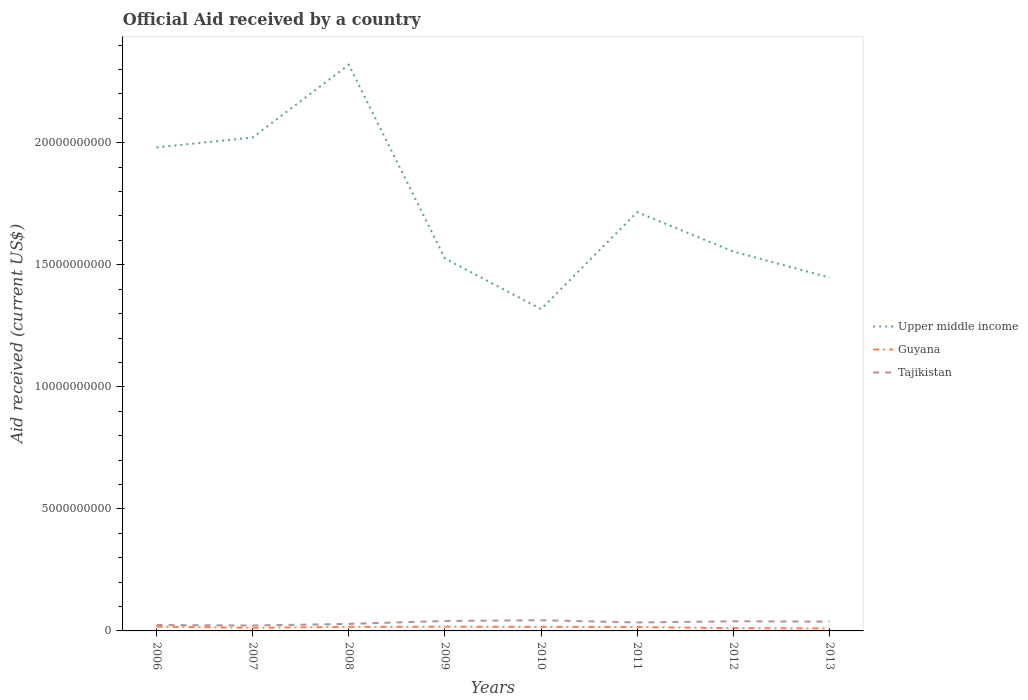How many different coloured lines are there?
Offer a terse response. 3. Is the number of lines equal to the number of legend labels?
Provide a succinct answer. Yes. Across all years, what is the maximum net official aid received in Upper middle income?
Your answer should be very brief. 1.32e+1. What is the total net official aid received in Guyana in the graph?
Offer a very short reply. 7.15e+07. What is the difference between the highest and the second highest net official aid received in Tajikistan?
Provide a succinct answer. 2.15e+08. What is the difference between the highest and the lowest net official aid received in Upper middle income?
Offer a terse response. 3. Is the net official aid received in Upper middle income strictly greater than the net official aid received in Tajikistan over the years?
Offer a very short reply. No. How many years are there in the graph?
Your response must be concise. 8. What is the difference between two consecutive major ticks on the Y-axis?
Give a very brief answer. 5.00e+09. Are the values on the major ticks of Y-axis written in scientific E-notation?
Provide a succinct answer. No. Does the graph contain any zero values?
Offer a very short reply. No. How many legend labels are there?
Provide a succinct answer. 3. How are the legend labels stacked?
Offer a very short reply. Vertical. What is the title of the graph?
Provide a succinct answer. Official Aid received by a country. What is the label or title of the X-axis?
Offer a very short reply. Years. What is the label or title of the Y-axis?
Your response must be concise. Aid received (current US$). What is the Aid received (current US$) in Upper middle income in 2006?
Give a very brief answer. 1.98e+1. What is the Aid received (current US$) of Guyana in 2006?
Provide a short and direct response. 1.74e+08. What is the Aid received (current US$) of Tajikistan in 2006?
Offer a terse response. 2.41e+08. What is the Aid received (current US$) of Upper middle income in 2007?
Offer a terse response. 2.02e+1. What is the Aid received (current US$) in Guyana in 2007?
Provide a succinct answer. 1.28e+08. What is the Aid received (current US$) of Tajikistan in 2007?
Offer a very short reply. 2.22e+08. What is the Aid received (current US$) in Upper middle income in 2008?
Keep it short and to the point. 2.32e+1. What is the Aid received (current US$) in Guyana in 2008?
Offer a terse response. 1.66e+08. What is the Aid received (current US$) in Tajikistan in 2008?
Keep it short and to the point. 2.89e+08. What is the Aid received (current US$) of Upper middle income in 2009?
Your answer should be compact. 1.53e+1. What is the Aid received (current US$) of Guyana in 2009?
Make the answer very short. 1.73e+08. What is the Aid received (current US$) in Tajikistan in 2009?
Ensure brevity in your answer.  4.08e+08. What is the Aid received (current US$) of Upper middle income in 2010?
Offer a terse response. 1.32e+1. What is the Aid received (current US$) in Guyana in 2010?
Your answer should be compact. 1.67e+08. What is the Aid received (current US$) of Tajikistan in 2010?
Offer a terse response. 4.37e+08. What is the Aid received (current US$) in Upper middle income in 2011?
Ensure brevity in your answer.  1.72e+1. What is the Aid received (current US$) of Guyana in 2011?
Offer a terse response. 1.59e+08. What is the Aid received (current US$) of Tajikistan in 2011?
Offer a terse response. 3.48e+08. What is the Aid received (current US$) of Upper middle income in 2012?
Your answer should be very brief. 1.55e+1. What is the Aid received (current US$) in Guyana in 2012?
Make the answer very short. 1.14e+08. What is the Aid received (current US$) of Tajikistan in 2012?
Your answer should be compact. 3.94e+08. What is the Aid received (current US$) of Upper middle income in 2013?
Make the answer very short. 1.45e+1. What is the Aid received (current US$) of Guyana in 2013?
Make the answer very short. 1.02e+08. What is the Aid received (current US$) of Tajikistan in 2013?
Your answer should be very brief. 3.82e+08. Across all years, what is the maximum Aid received (current US$) of Upper middle income?
Your answer should be very brief. 2.32e+1. Across all years, what is the maximum Aid received (current US$) of Guyana?
Your response must be concise. 1.74e+08. Across all years, what is the maximum Aid received (current US$) in Tajikistan?
Provide a succinct answer. 4.37e+08. Across all years, what is the minimum Aid received (current US$) of Upper middle income?
Provide a short and direct response. 1.32e+1. Across all years, what is the minimum Aid received (current US$) of Guyana?
Make the answer very short. 1.02e+08. Across all years, what is the minimum Aid received (current US$) in Tajikistan?
Give a very brief answer. 2.22e+08. What is the total Aid received (current US$) in Upper middle income in the graph?
Keep it short and to the point. 1.39e+11. What is the total Aid received (current US$) of Guyana in the graph?
Offer a very short reply. 1.18e+09. What is the total Aid received (current US$) of Tajikistan in the graph?
Your response must be concise. 2.72e+09. What is the difference between the Aid received (current US$) of Upper middle income in 2006 and that in 2007?
Your answer should be compact. -4.08e+08. What is the difference between the Aid received (current US$) in Guyana in 2006 and that in 2007?
Provide a succinct answer. 4.65e+07. What is the difference between the Aid received (current US$) of Tajikistan in 2006 and that in 2007?
Give a very brief answer. 1.91e+07. What is the difference between the Aid received (current US$) of Upper middle income in 2006 and that in 2008?
Your response must be concise. -3.39e+09. What is the difference between the Aid received (current US$) in Guyana in 2006 and that in 2008?
Make the answer very short. 8.04e+06. What is the difference between the Aid received (current US$) of Tajikistan in 2006 and that in 2008?
Provide a short and direct response. -4.74e+07. What is the difference between the Aid received (current US$) of Upper middle income in 2006 and that in 2009?
Give a very brief answer. 4.55e+09. What is the difference between the Aid received (current US$) in Guyana in 2006 and that in 2009?
Your answer should be very brief. 9.70e+05. What is the difference between the Aid received (current US$) in Tajikistan in 2006 and that in 2009?
Offer a very short reply. -1.67e+08. What is the difference between the Aid received (current US$) of Upper middle income in 2006 and that in 2010?
Your answer should be very brief. 6.62e+09. What is the difference between the Aid received (current US$) of Guyana in 2006 and that in 2010?
Ensure brevity in your answer.  7.29e+06. What is the difference between the Aid received (current US$) in Tajikistan in 2006 and that in 2010?
Offer a terse response. -1.95e+08. What is the difference between the Aid received (current US$) in Upper middle income in 2006 and that in 2011?
Your answer should be very brief. 2.65e+09. What is the difference between the Aid received (current US$) in Guyana in 2006 and that in 2011?
Make the answer very short. 1.56e+07. What is the difference between the Aid received (current US$) of Tajikistan in 2006 and that in 2011?
Keep it short and to the point. -1.06e+08. What is the difference between the Aid received (current US$) in Upper middle income in 2006 and that in 2012?
Offer a terse response. 4.26e+09. What is the difference between the Aid received (current US$) of Guyana in 2006 and that in 2012?
Provide a short and direct response. 5.99e+07. What is the difference between the Aid received (current US$) of Tajikistan in 2006 and that in 2012?
Offer a very short reply. -1.53e+08. What is the difference between the Aid received (current US$) of Upper middle income in 2006 and that in 2013?
Give a very brief answer. 5.33e+09. What is the difference between the Aid received (current US$) of Guyana in 2006 and that in 2013?
Make the answer very short. 7.24e+07. What is the difference between the Aid received (current US$) in Tajikistan in 2006 and that in 2013?
Offer a very short reply. -1.41e+08. What is the difference between the Aid received (current US$) in Upper middle income in 2007 and that in 2008?
Keep it short and to the point. -2.98e+09. What is the difference between the Aid received (current US$) in Guyana in 2007 and that in 2008?
Your answer should be very brief. -3.84e+07. What is the difference between the Aid received (current US$) of Tajikistan in 2007 and that in 2008?
Offer a terse response. -6.66e+07. What is the difference between the Aid received (current US$) of Upper middle income in 2007 and that in 2009?
Your answer should be compact. 4.96e+09. What is the difference between the Aid received (current US$) in Guyana in 2007 and that in 2009?
Your response must be concise. -4.55e+07. What is the difference between the Aid received (current US$) in Tajikistan in 2007 and that in 2009?
Provide a short and direct response. -1.86e+08. What is the difference between the Aid received (current US$) in Upper middle income in 2007 and that in 2010?
Ensure brevity in your answer.  7.03e+09. What is the difference between the Aid received (current US$) in Guyana in 2007 and that in 2010?
Your response must be concise. -3.92e+07. What is the difference between the Aid received (current US$) in Tajikistan in 2007 and that in 2010?
Your answer should be compact. -2.15e+08. What is the difference between the Aid received (current US$) of Upper middle income in 2007 and that in 2011?
Make the answer very short. 3.06e+09. What is the difference between the Aid received (current US$) in Guyana in 2007 and that in 2011?
Your answer should be compact. -3.09e+07. What is the difference between the Aid received (current US$) of Tajikistan in 2007 and that in 2011?
Provide a short and direct response. -1.25e+08. What is the difference between the Aid received (current US$) of Upper middle income in 2007 and that in 2012?
Your response must be concise. 4.67e+09. What is the difference between the Aid received (current US$) of Guyana in 2007 and that in 2012?
Give a very brief answer. 1.34e+07. What is the difference between the Aid received (current US$) of Tajikistan in 2007 and that in 2012?
Make the answer very short. -1.72e+08. What is the difference between the Aid received (current US$) in Upper middle income in 2007 and that in 2013?
Ensure brevity in your answer.  5.74e+09. What is the difference between the Aid received (current US$) of Guyana in 2007 and that in 2013?
Keep it short and to the point. 2.60e+07. What is the difference between the Aid received (current US$) of Tajikistan in 2007 and that in 2013?
Your answer should be compact. -1.60e+08. What is the difference between the Aid received (current US$) in Upper middle income in 2008 and that in 2009?
Give a very brief answer. 7.94e+09. What is the difference between the Aid received (current US$) of Guyana in 2008 and that in 2009?
Offer a terse response. -7.07e+06. What is the difference between the Aid received (current US$) of Tajikistan in 2008 and that in 2009?
Provide a short and direct response. -1.19e+08. What is the difference between the Aid received (current US$) in Upper middle income in 2008 and that in 2010?
Provide a short and direct response. 1.00e+1. What is the difference between the Aid received (current US$) of Guyana in 2008 and that in 2010?
Provide a succinct answer. -7.50e+05. What is the difference between the Aid received (current US$) in Tajikistan in 2008 and that in 2010?
Ensure brevity in your answer.  -1.48e+08. What is the difference between the Aid received (current US$) in Upper middle income in 2008 and that in 2011?
Give a very brief answer. 6.04e+09. What is the difference between the Aid received (current US$) in Guyana in 2008 and that in 2011?
Make the answer very short. 7.51e+06. What is the difference between the Aid received (current US$) in Tajikistan in 2008 and that in 2011?
Ensure brevity in your answer.  -5.88e+07. What is the difference between the Aid received (current US$) in Upper middle income in 2008 and that in 2012?
Offer a terse response. 7.65e+09. What is the difference between the Aid received (current US$) in Guyana in 2008 and that in 2012?
Offer a very short reply. 5.18e+07. What is the difference between the Aid received (current US$) in Tajikistan in 2008 and that in 2012?
Offer a very short reply. -1.05e+08. What is the difference between the Aid received (current US$) in Upper middle income in 2008 and that in 2013?
Make the answer very short. 8.72e+09. What is the difference between the Aid received (current US$) in Guyana in 2008 and that in 2013?
Keep it short and to the point. 6.44e+07. What is the difference between the Aid received (current US$) of Tajikistan in 2008 and that in 2013?
Offer a very short reply. -9.35e+07. What is the difference between the Aid received (current US$) in Upper middle income in 2009 and that in 2010?
Your answer should be compact. 2.07e+09. What is the difference between the Aid received (current US$) in Guyana in 2009 and that in 2010?
Offer a very short reply. 6.32e+06. What is the difference between the Aid received (current US$) of Tajikistan in 2009 and that in 2010?
Keep it short and to the point. -2.85e+07. What is the difference between the Aid received (current US$) of Upper middle income in 2009 and that in 2011?
Your response must be concise. -1.90e+09. What is the difference between the Aid received (current US$) in Guyana in 2009 and that in 2011?
Make the answer very short. 1.46e+07. What is the difference between the Aid received (current US$) in Tajikistan in 2009 and that in 2011?
Ensure brevity in your answer.  6.06e+07. What is the difference between the Aid received (current US$) in Upper middle income in 2009 and that in 2012?
Provide a short and direct response. -2.86e+08. What is the difference between the Aid received (current US$) of Guyana in 2009 and that in 2012?
Provide a short and direct response. 5.89e+07. What is the difference between the Aid received (current US$) of Tajikistan in 2009 and that in 2012?
Your response must be concise. 1.42e+07. What is the difference between the Aid received (current US$) of Upper middle income in 2009 and that in 2013?
Provide a short and direct response. 7.81e+08. What is the difference between the Aid received (current US$) in Guyana in 2009 and that in 2013?
Give a very brief answer. 7.15e+07. What is the difference between the Aid received (current US$) of Tajikistan in 2009 and that in 2013?
Provide a short and direct response. 2.59e+07. What is the difference between the Aid received (current US$) of Upper middle income in 2010 and that in 2011?
Your answer should be compact. -3.97e+09. What is the difference between the Aid received (current US$) of Guyana in 2010 and that in 2011?
Your answer should be compact. 8.26e+06. What is the difference between the Aid received (current US$) in Tajikistan in 2010 and that in 2011?
Ensure brevity in your answer.  8.91e+07. What is the difference between the Aid received (current US$) in Upper middle income in 2010 and that in 2012?
Your response must be concise. -2.36e+09. What is the difference between the Aid received (current US$) of Guyana in 2010 and that in 2012?
Provide a succinct answer. 5.26e+07. What is the difference between the Aid received (current US$) in Tajikistan in 2010 and that in 2012?
Provide a short and direct response. 4.27e+07. What is the difference between the Aid received (current US$) in Upper middle income in 2010 and that in 2013?
Provide a succinct answer. -1.29e+09. What is the difference between the Aid received (current US$) in Guyana in 2010 and that in 2013?
Your answer should be very brief. 6.52e+07. What is the difference between the Aid received (current US$) in Tajikistan in 2010 and that in 2013?
Your answer should be compact. 5.44e+07. What is the difference between the Aid received (current US$) of Upper middle income in 2011 and that in 2012?
Make the answer very short. 1.62e+09. What is the difference between the Aid received (current US$) in Guyana in 2011 and that in 2012?
Offer a very short reply. 4.43e+07. What is the difference between the Aid received (current US$) of Tajikistan in 2011 and that in 2012?
Provide a succinct answer. -4.64e+07. What is the difference between the Aid received (current US$) in Upper middle income in 2011 and that in 2013?
Your answer should be very brief. 2.68e+09. What is the difference between the Aid received (current US$) in Guyana in 2011 and that in 2013?
Provide a succinct answer. 5.69e+07. What is the difference between the Aid received (current US$) in Tajikistan in 2011 and that in 2013?
Your answer should be very brief. -3.47e+07. What is the difference between the Aid received (current US$) of Upper middle income in 2012 and that in 2013?
Offer a terse response. 1.07e+09. What is the difference between the Aid received (current US$) in Guyana in 2012 and that in 2013?
Your answer should be compact. 1.26e+07. What is the difference between the Aid received (current US$) of Tajikistan in 2012 and that in 2013?
Offer a very short reply. 1.17e+07. What is the difference between the Aid received (current US$) in Upper middle income in 2006 and the Aid received (current US$) in Guyana in 2007?
Make the answer very short. 1.97e+1. What is the difference between the Aid received (current US$) in Upper middle income in 2006 and the Aid received (current US$) in Tajikistan in 2007?
Ensure brevity in your answer.  1.96e+1. What is the difference between the Aid received (current US$) in Guyana in 2006 and the Aid received (current US$) in Tajikistan in 2007?
Give a very brief answer. -4.78e+07. What is the difference between the Aid received (current US$) in Upper middle income in 2006 and the Aid received (current US$) in Guyana in 2008?
Give a very brief answer. 1.96e+1. What is the difference between the Aid received (current US$) in Upper middle income in 2006 and the Aid received (current US$) in Tajikistan in 2008?
Your answer should be very brief. 1.95e+1. What is the difference between the Aid received (current US$) in Guyana in 2006 and the Aid received (current US$) in Tajikistan in 2008?
Provide a short and direct response. -1.14e+08. What is the difference between the Aid received (current US$) in Upper middle income in 2006 and the Aid received (current US$) in Guyana in 2009?
Your answer should be compact. 1.96e+1. What is the difference between the Aid received (current US$) in Upper middle income in 2006 and the Aid received (current US$) in Tajikistan in 2009?
Give a very brief answer. 1.94e+1. What is the difference between the Aid received (current US$) of Guyana in 2006 and the Aid received (current US$) of Tajikistan in 2009?
Offer a very short reply. -2.34e+08. What is the difference between the Aid received (current US$) of Upper middle income in 2006 and the Aid received (current US$) of Guyana in 2010?
Your answer should be very brief. 1.96e+1. What is the difference between the Aid received (current US$) in Upper middle income in 2006 and the Aid received (current US$) in Tajikistan in 2010?
Provide a short and direct response. 1.94e+1. What is the difference between the Aid received (current US$) in Guyana in 2006 and the Aid received (current US$) in Tajikistan in 2010?
Offer a terse response. -2.62e+08. What is the difference between the Aid received (current US$) of Upper middle income in 2006 and the Aid received (current US$) of Guyana in 2011?
Make the answer very short. 1.96e+1. What is the difference between the Aid received (current US$) in Upper middle income in 2006 and the Aid received (current US$) in Tajikistan in 2011?
Offer a terse response. 1.95e+1. What is the difference between the Aid received (current US$) of Guyana in 2006 and the Aid received (current US$) of Tajikistan in 2011?
Offer a terse response. -1.73e+08. What is the difference between the Aid received (current US$) of Upper middle income in 2006 and the Aid received (current US$) of Guyana in 2012?
Make the answer very short. 1.97e+1. What is the difference between the Aid received (current US$) of Upper middle income in 2006 and the Aid received (current US$) of Tajikistan in 2012?
Your answer should be very brief. 1.94e+1. What is the difference between the Aid received (current US$) in Guyana in 2006 and the Aid received (current US$) in Tajikistan in 2012?
Offer a very short reply. -2.20e+08. What is the difference between the Aid received (current US$) of Upper middle income in 2006 and the Aid received (current US$) of Guyana in 2013?
Provide a short and direct response. 1.97e+1. What is the difference between the Aid received (current US$) in Upper middle income in 2006 and the Aid received (current US$) in Tajikistan in 2013?
Your answer should be very brief. 1.94e+1. What is the difference between the Aid received (current US$) in Guyana in 2006 and the Aid received (current US$) in Tajikistan in 2013?
Your answer should be compact. -2.08e+08. What is the difference between the Aid received (current US$) of Upper middle income in 2007 and the Aid received (current US$) of Guyana in 2008?
Your answer should be very brief. 2.00e+1. What is the difference between the Aid received (current US$) in Upper middle income in 2007 and the Aid received (current US$) in Tajikistan in 2008?
Offer a terse response. 1.99e+1. What is the difference between the Aid received (current US$) of Guyana in 2007 and the Aid received (current US$) of Tajikistan in 2008?
Offer a very short reply. -1.61e+08. What is the difference between the Aid received (current US$) in Upper middle income in 2007 and the Aid received (current US$) in Guyana in 2009?
Make the answer very short. 2.00e+1. What is the difference between the Aid received (current US$) of Upper middle income in 2007 and the Aid received (current US$) of Tajikistan in 2009?
Keep it short and to the point. 1.98e+1. What is the difference between the Aid received (current US$) in Guyana in 2007 and the Aid received (current US$) in Tajikistan in 2009?
Give a very brief answer. -2.80e+08. What is the difference between the Aid received (current US$) in Upper middle income in 2007 and the Aid received (current US$) in Guyana in 2010?
Provide a succinct answer. 2.00e+1. What is the difference between the Aid received (current US$) of Upper middle income in 2007 and the Aid received (current US$) of Tajikistan in 2010?
Your answer should be compact. 1.98e+1. What is the difference between the Aid received (current US$) of Guyana in 2007 and the Aid received (current US$) of Tajikistan in 2010?
Provide a short and direct response. -3.09e+08. What is the difference between the Aid received (current US$) in Upper middle income in 2007 and the Aid received (current US$) in Guyana in 2011?
Ensure brevity in your answer.  2.01e+1. What is the difference between the Aid received (current US$) of Upper middle income in 2007 and the Aid received (current US$) of Tajikistan in 2011?
Make the answer very short. 1.99e+1. What is the difference between the Aid received (current US$) in Guyana in 2007 and the Aid received (current US$) in Tajikistan in 2011?
Provide a short and direct response. -2.20e+08. What is the difference between the Aid received (current US$) in Upper middle income in 2007 and the Aid received (current US$) in Guyana in 2012?
Provide a succinct answer. 2.01e+1. What is the difference between the Aid received (current US$) of Upper middle income in 2007 and the Aid received (current US$) of Tajikistan in 2012?
Make the answer very short. 1.98e+1. What is the difference between the Aid received (current US$) of Guyana in 2007 and the Aid received (current US$) of Tajikistan in 2012?
Make the answer very short. -2.66e+08. What is the difference between the Aid received (current US$) of Upper middle income in 2007 and the Aid received (current US$) of Guyana in 2013?
Your response must be concise. 2.01e+1. What is the difference between the Aid received (current US$) in Upper middle income in 2007 and the Aid received (current US$) in Tajikistan in 2013?
Provide a short and direct response. 1.98e+1. What is the difference between the Aid received (current US$) of Guyana in 2007 and the Aid received (current US$) of Tajikistan in 2013?
Provide a short and direct response. -2.54e+08. What is the difference between the Aid received (current US$) of Upper middle income in 2008 and the Aid received (current US$) of Guyana in 2009?
Ensure brevity in your answer.  2.30e+1. What is the difference between the Aid received (current US$) in Upper middle income in 2008 and the Aid received (current US$) in Tajikistan in 2009?
Ensure brevity in your answer.  2.28e+1. What is the difference between the Aid received (current US$) in Guyana in 2008 and the Aid received (current US$) in Tajikistan in 2009?
Make the answer very short. -2.42e+08. What is the difference between the Aid received (current US$) in Upper middle income in 2008 and the Aid received (current US$) in Guyana in 2010?
Keep it short and to the point. 2.30e+1. What is the difference between the Aid received (current US$) of Upper middle income in 2008 and the Aid received (current US$) of Tajikistan in 2010?
Provide a short and direct response. 2.28e+1. What is the difference between the Aid received (current US$) of Guyana in 2008 and the Aid received (current US$) of Tajikistan in 2010?
Keep it short and to the point. -2.70e+08. What is the difference between the Aid received (current US$) in Upper middle income in 2008 and the Aid received (current US$) in Guyana in 2011?
Provide a short and direct response. 2.30e+1. What is the difference between the Aid received (current US$) in Upper middle income in 2008 and the Aid received (current US$) in Tajikistan in 2011?
Provide a succinct answer. 2.28e+1. What is the difference between the Aid received (current US$) of Guyana in 2008 and the Aid received (current US$) of Tajikistan in 2011?
Keep it short and to the point. -1.81e+08. What is the difference between the Aid received (current US$) in Upper middle income in 2008 and the Aid received (current US$) in Guyana in 2012?
Keep it short and to the point. 2.31e+1. What is the difference between the Aid received (current US$) of Upper middle income in 2008 and the Aid received (current US$) of Tajikistan in 2012?
Make the answer very short. 2.28e+1. What is the difference between the Aid received (current US$) of Guyana in 2008 and the Aid received (current US$) of Tajikistan in 2012?
Your answer should be very brief. -2.28e+08. What is the difference between the Aid received (current US$) of Upper middle income in 2008 and the Aid received (current US$) of Guyana in 2013?
Offer a very short reply. 2.31e+1. What is the difference between the Aid received (current US$) in Upper middle income in 2008 and the Aid received (current US$) in Tajikistan in 2013?
Keep it short and to the point. 2.28e+1. What is the difference between the Aid received (current US$) in Guyana in 2008 and the Aid received (current US$) in Tajikistan in 2013?
Give a very brief answer. -2.16e+08. What is the difference between the Aid received (current US$) of Upper middle income in 2009 and the Aid received (current US$) of Guyana in 2010?
Offer a very short reply. 1.51e+1. What is the difference between the Aid received (current US$) of Upper middle income in 2009 and the Aid received (current US$) of Tajikistan in 2010?
Offer a very short reply. 1.48e+1. What is the difference between the Aid received (current US$) in Guyana in 2009 and the Aid received (current US$) in Tajikistan in 2010?
Ensure brevity in your answer.  -2.63e+08. What is the difference between the Aid received (current US$) of Upper middle income in 2009 and the Aid received (current US$) of Guyana in 2011?
Keep it short and to the point. 1.51e+1. What is the difference between the Aid received (current US$) of Upper middle income in 2009 and the Aid received (current US$) of Tajikistan in 2011?
Your answer should be very brief. 1.49e+1. What is the difference between the Aid received (current US$) in Guyana in 2009 and the Aid received (current US$) in Tajikistan in 2011?
Offer a very short reply. -1.74e+08. What is the difference between the Aid received (current US$) in Upper middle income in 2009 and the Aid received (current US$) in Guyana in 2012?
Your response must be concise. 1.51e+1. What is the difference between the Aid received (current US$) in Upper middle income in 2009 and the Aid received (current US$) in Tajikistan in 2012?
Your response must be concise. 1.49e+1. What is the difference between the Aid received (current US$) of Guyana in 2009 and the Aid received (current US$) of Tajikistan in 2012?
Make the answer very short. -2.21e+08. What is the difference between the Aid received (current US$) of Upper middle income in 2009 and the Aid received (current US$) of Guyana in 2013?
Give a very brief answer. 1.52e+1. What is the difference between the Aid received (current US$) in Upper middle income in 2009 and the Aid received (current US$) in Tajikistan in 2013?
Your response must be concise. 1.49e+1. What is the difference between the Aid received (current US$) of Guyana in 2009 and the Aid received (current US$) of Tajikistan in 2013?
Your answer should be very brief. -2.09e+08. What is the difference between the Aid received (current US$) in Upper middle income in 2010 and the Aid received (current US$) in Guyana in 2011?
Provide a short and direct response. 1.30e+1. What is the difference between the Aid received (current US$) of Upper middle income in 2010 and the Aid received (current US$) of Tajikistan in 2011?
Your answer should be very brief. 1.28e+1. What is the difference between the Aid received (current US$) in Guyana in 2010 and the Aid received (current US$) in Tajikistan in 2011?
Provide a short and direct response. -1.80e+08. What is the difference between the Aid received (current US$) in Upper middle income in 2010 and the Aid received (current US$) in Guyana in 2012?
Your answer should be very brief. 1.31e+1. What is the difference between the Aid received (current US$) of Upper middle income in 2010 and the Aid received (current US$) of Tajikistan in 2012?
Offer a terse response. 1.28e+1. What is the difference between the Aid received (current US$) of Guyana in 2010 and the Aid received (current US$) of Tajikistan in 2012?
Offer a terse response. -2.27e+08. What is the difference between the Aid received (current US$) of Upper middle income in 2010 and the Aid received (current US$) of Guyana in 2013?
Provide a succinct answer. 1.31e+1. What is the difference between the Aid received (current US$) in Upper middle income in 2010 and the Aid received (current US$) in Tajikistan in 2013?
Keep it short and to the point. 1.28e+1. What is the difference between the Aid received (current US$) of Guyana in 2010 and the Aid received (current US$) of Tajikistan in 2013?
Provide a succinct answer. -2.15e+08. What is the difference between the Aid received (current US$) in Upper middle income in 2011 and the Aid received (current US$) in Guyana in 2012?
Offer a very short reply. 1.70e+1. What is the difference between the Aid received (current US$) in Upper middle income in 2011 and the Aid received (current US$) in Tajikistan in 2012?
Give a very brief answer. 1.68e+1. What is the difference between the Aid received (current US$) in Guyana in 2011 and the Aid received (current US$) in Tajikistan in 2012?
Keep it short and to the point. -2.35e+08. What is the difference between the Aid received (current US$) of Upper middle income in 2011 and the Aid received (current US$) of Guyana in 2013?
Offer a terse response. 1.71e+1. What is the difference between the Aid received (current US$) of Upper middle income in 2011 and the Aid received (current US$) of Tajikistan in 2013?
Keep it short and to the point. 1.68e+1. What is the difference between the Aid received (current US$) of Guyana in 2011 and the Aid received (current US$) of Tajikistan in 2013?
Ensure brevity in your answer.  -2.23e+08. What is the difference between the Aid received (current US$) of Upper middle income in 2012 and the Aid received (current US$) of Guyana in 2013?
Provide a short and direct response. 1.54e+1. What is the difference between the Aid received (current US$) in Upper middle income in 2012 and the Aid received (current US$) in Tajikistan in 2013?
Provide a succinct answer. 1.52e+1. What is the difference between the Aid received (current US$) of Guyana in 2012 and the Aid received (current US$) of Tajikistan in 2013?
Provide a short and direct response. -2.68e+08. What is the average Aid received (current US$) in Upper middle income per year?
Your answer should be compact. 1.74e+1. What is the average Aid received (current US$) in Guyana per year?
Ensure brevity in your answer.  1.48e+08. What is the average Aid received (current US$) in Tajikistan per year?
Provide a short and direct response. 3.40e+08. In the year 2006, what is the difference between the Aid received (current US$) in Upper middle income and Aid received (current US$) in Guyana?
Give a very brief answer. 1.96e+1. In the year 2006, what is the difference between the Aid received (current US$) in Upper middle income and Aid received (current US$) in Tajikistan?
Give a very brief answer. 1.96e+1. In the year 2006, what is the difference between the Aid received (current US$) in Guyana and Aid received (current US$) in Tajikistan?
Provide a succinct answer. -6.69e+07. In the year 2007, what is the difference between the Aid received (current US$) in Upper middle income and Aid received (current US$) in Guyana?
Your response must be concise. 2.01e+1. In the year 2007, what is the difference between the Aid received (current US$) in Upper middle income and Aid received (current US$) in Tajikistan?
Your response must be concise. 2.00e+1. In the year 2007, what is the difference between the Aid received (current US$) of Guyana and Aid received (current US$) of Tajikistan?
Your response must be concise. -9.43e+07. In the year 2008, what is the difference between the Aid received (current US$) of Upper middle income and Aid received (current US$) of Guyana?
Provide a short and direct response. 2.30e+1. In the year 2008, what is the difference between the Aid received (current US$) in Upper middle income and Aid received (current US$) in Tajikistan?
Provide a short and direct response. 2.29e+1. In the year 2008, what is the difference between the Aid received (current US$) in Guyana and Aid received (current US$) in Tajikistan?
Your response must be concise. -1.22e+08. In the year 2009, what is the difference between the Aid received (current US$) in Upper middle income and Aid received (current US$) in Guyana?
Your response must be concise. 1.51e+1. In the year 2009, what is the difference between the Aid received (current US$) of Upper middle income and Aid received (current US$) of Tajikistan?
Your answer should be very brief. 1.48e+1. In the year 2009, what is the difference between the Aid received (current US$) of Guyana and Aid received (current US$) of Tajikistan?
Your answer should be very brief. -2.35e+08. In the year 2010, what is the difference between the Aid received (current US$) of Upper middle income and Aid received (current US$) of Guyana?
Provide a succinct answer. 1.30e+1. In the year 2010, what is the difference between the Aid received (current US$) in Upper middle income and Aid received (current US$) in Tajikistan?
Your answer should be compact. 1.27e+1. In the year 2010, what is the difference between the Aid received (current US$) of Guyana and Aid received (current US$) of Tajikistan?
Give a very brief answer. -2.70e+08. In the year 2011, what is the difference between the Aid received (current US$) of Upper middle income and Aid received (current US$) of Guyana?
Your answer should be compact. 1.70e+1. In the year 2011, what is the difference between the Aid received (current US$) of Upper middle income and Aid received (current US$) of Tajikistan?
Ensure brevity in your answer.  1.68e+1. In the year 2011, what is the difference between the Aid received (current US$) of Guyana and Aid received (current US$) of Tajikistan?
Offer a terse response. -1.89e+08. In the year 2012, what is the difference between the Aid received (current US$) in Upper middle income and Aid received (current US$) in Guyana?
Keep it short and to the point. 1.54e+1. In the year 2012, what is the difference between the Aid received (current US$) in Upper middle income and Aid received (current US$) in Tajikistan?
Your answer should be compact. 1.51e+1. In the year 2012, what is the difference between the Aid received (current US$) in Guyana and Aid received (current US$) in Tajikistan?
Your answer should be very brief. -2.79e+08. In the year 2013, what is the difference between the Aid received (current US$) of Upper middle income and Aid received (current US$) of Guyana?
Your answer should be compact. 1.44e+1. In the year 2013, what is the difference between the Aid received (current US$) in Upper middle income and Aid received (current US$) in Tajikistan?
Give a very brief answer. 1.41e+1. In the year 2013, what is the difference between the Aid received (current US$) of Guyana and Aid received (current US$) of Tajikistan?
Offer a very short reply. -2.80e+08. What is the ratio of the Aid received (current US$) in Upper middle income in 2006 to that in 2007?
Give a very brief answer. 0.98. What is the ratio of the Aid received (current US$) of Guyana in 2006 to that in 2007?
Offer a terse response. 1.36. What is the ratio of the Aid received (current US$) in Tajikistan in 2006 to that in 2007?
Offer a terse response. 1.09. What is the ratio of the Aid received (current US$) in Upper middle income in 2006 to that in 2008?
Your answer should be very brief. 0.85. What is the ratio of the Aid received (current US$) of Guyana in 2006 to that in 2008?
Offer a terse response. 1.05. What is the ratio of the Aid received (current US$) in Tajikistan in 2006 to that in 2008?
Provide a succinct answer. 0.84. What is the ratio of the Aid received (current US$) of Upper middle income in 2006 to that in 2009?
Give a very brief answer. 1.3. What is the ratio of the Aid received (current US$) in Guyana in 2006 to that in 2009?
Offer a terse response. 1.01. What is the ratio of the Aid received (current US$) of Tajikistan in 2006 to that in 2009?
Your response must be concise. 0.59. What is the ratio of the Aid received (current US$) in Upper middle income in 2006 to that in 2010?
Your answer should be very brief. 1.5. What is the ratio of the Aid received (current US$) in Guyana in 2006 to that in 2010?
Keep it short and to the point. 1.04. What is the ratio of the Aid received (current US$) of Tajikistan in 2006 to that in 2010?
Ensure brevity in your answer.  0.55. What is the ratio of the Aid received (current US$) of Upper middle income in 2006 to that in 2011?
Ensure brevity in your answer.  1.15. What is the ratio of the Aid received (current US$) of Guyana in 2006 to that in 2011?
Your response must be concise. 1.1. What is the ratio of the Aid received (current US$) in Tajikistan in 2006 to that in 2011?
Provide a short and direct response. 0.69. What is the ratio of the Aid received (current US$) of Upper middle income in 2006 to that in 2012?
Your answer should be very brief. 1.27. What is the ratio of the Aid received (current US$) in Guyana in 2006 to that in 2012?
Provide a short and direct response. 1.52. What is the ratio of the Aid received (current US$) of Tajikistan in 2006 to that in 2012?
Give a very brief answer. 0.61. What is the ratio of the Aid received (current US$) in Upper middle income in 2006 to that in 2013?
Provide a succinct answer. 1.37. What is the ratio of the Aid received (current US$) of Guyana in 2006 to that in 2013?
Give a very brief answer. 1.71. What is the ratio of the Aid received (current US$) in Tajikistan in 2006 to that in 2013?
Provide a succinct answer. 0.63. What is the ratio of the Aid received (current US$) of Upper middle income in 2007 to that in 2008?
Offer a very short reply. 0.87. What is the ratio of the Aid received (current US$) in Guyana in 2007 to that in 2008?
Keep it short and to the point. 0.77. What is the ratio of the Aid received (current US$) in Tajikistan in 2007 to that in 2008?
Ensure brevity in your answer.  0.77. What is the ratio of the Aid received (current US$) of Upper middle income in 2007 to that in 2009?
Your answer should be very brief. 1.33. What is the ratio of the Aid received (current US$) in Guyana in 2007 to that in 2009?
Make the answer very short. 0.74. What is the ratio of the Aid received (current US$) in Tajikistan in 2007 to that in 2009?
Offer a terse response. 0.54. What is the ratio of the Aid received (current US$) in Upper middle income in 2007 to that in 2010?
Your answer should be compact. 1.53. What is the ratio of the Aid received (current US$) in Guyana in 2007 to that in 2010?
Your answer should be compact. 0.77. What is the ratio of the Aid received (current US$) in Tajikistan in 2007 to that in 2010?
Make the answer very short. 0.51. What is the ratio of the Aid received (current US$) of Upper middle income in 2007 to that in 2011?
Offer a very short reply. 1.18. What is the ratio of the Aid received (current US$) of Guyana in 2007 to that in 2011?
Provide a succinct answer. 0.81. What is the ratio of the Aid received (current US$) in Tajikistan in 2007 to that in 2011?
Keep it short and to the point. 0.64. What is the ratio of the Aid received (current US$) of Upper middle income in 2007 to that in 2012?
Offer a very short reply. 1.3. What is the ratio of the Aid received (current US$) of Guyana in 2007 to that in 2012?
Provide a succinct answer. 1.12. What is the ratio of the Aid received (current US$) in Tajikistan in 2007 to that in 2012?
Make the answer very short. 0.56. What is the ratio of the Aid received (current US$) of Upper middle income in 2007 to that in 2013?
Give a very brief answer. 1.4. What is the ratio of the Aid received (current US$) in Guyana in 2007 to that in 2013?
Give a very brief answer. 1.25. What is the ratio of the Aid received (current US$) of Tajikistan in 2007 to that in 2013?
Your response must be concise. 0.58. What is the ratio of the Aid received (current US$) in Upper middle income in 2008 to that in 2009?
Ensure brevity in your answer.  1.52. What is the ratio of the Aid received (current US$) in Guyana in 2008 to that in 2009?
Your answer should be compact. 0.96. What is the ratio of the Aid received (current US$) of Tajikistan in 2008 to that in 2009?
Keep it short and to the point. 0.71. What is the ratio of the Aid received (current US$) in Upper middle income in 2008 to that in 2010?
Offer a terse response. 1.76. What is the ratio of the Aid received (current US$) of Tajikistan in 2008 to that in 2010?
Your response must be concise. 0.66. What is the ratio of the Aid received (current US$) of Upper middle income in 2008 to that in 2011?
Make the answer very short. 1.35. What is the ratio of the Aid received (current US$) in Guyana in 2008 to that in 2011?
Give a very brief answer. 1.05. What is the ratio of the Aid received (current US$) of Tajikistan in 2008 to that in 2011?
Offer a terse response. 0.83. What is the ratio of the Aid received (current US$) in Upper middle income in 2008 to that in 2012?
Make the answer very short. 1.49. What is the ratio of the Aid received (current US$) of Guyana in 2008 to that in 2012?
Provide a succinct answer. 1.45. What is the ratio of the Aid received (current US$) of Tajikistan in 2008 to that in 2012?
Provide a succinct answer. 0.73. What is the ratio of the Aid received (current US$) of Upper middle income in 2008 to that in 2013?
Your answer should be very brief. 1.6. What is the ratio of the Aid received (current US$) of Guyana in 2008 to that in 2013?
Your answer should be compact. 1.63. What is the ratio of the Aid received (current US$) of Tajikistan in 2008 to that in 2013?
Provide a short and direct response. 0.76. What is the ratio of the Aid received (current US$) in Upper middle income in 2009 to that in 2010?
Your answer should be compact. 1.16. What is the ratio of the Aid received (current US$) of Guyana in 2009 to that in 2010?
Keep it short and to the point. 1.04. What is the ratio of the Aid received (current US$) in Tajikistan in 2009 to that in 2010?
Provide a succinct answer. 0.93. What is the ratio of the Aid received (current US$) in Upper middle income in 2009 to that in 2011?
Your answer should be very brief. 0.89. What is the ratio of the Aid received (current US$) in Guyana in 2009 to that in 2011?
Keep it short and to the point. 1.09. What is the ratio of the Aid received (current US$) in Tajikistan in 2009 to that in 2011?
Ensure brevity in your answer.  1.17. What is the ratio of the Aid received (current US$) in Upper middle income in 2009 to that in 2012?
Give a very brief answer. 0.98. What is the ratio of the Aid received (current US$) in Guyana in 2009 to that in 2012?
Offer a very short reply. 1.51. What is the ratio of the Aid received (current US$) of Tajikistan in 2009 to that in 2012?
Keep it short and to the point. 1.04. What is the ratio of the Aid received (current US$) in Upper middle income in 2009 to that in 2013?
Your answer should be compact. 1.05. What is the ratio of the Aid received (current US$) of Guyana in 2009 to that in 2013?
Provide a short and direct response. 1.7. What is the ratio of the Aid received (current US$) in Tajikistan in 2009 to that in 2013?
Your answer should be very brief. 1.07. What is the ratio of the Aid received (current US$) of Upper middle income in 2010 to that in 2011?
Provide a short and direct response. 0.77. What is the ratio of the Aid received (current US$) of Guyana in 2010 to that in 2011?
Your response must be concise. 1.05. What is the ratio of the Aid received (current US$) in Tajikistan in 2010 to that in 2011?
Your answer should be compact. 1.26. What is the ratio of the Aid received (current US$) in Upper middle income in 2010 to that in 2012?
Ensure brevity in your answer.  0.85. What is the ratio of the Aid received (current US$) of Guyana in 2010 to that in 2012?
Offer a terse response. 1.46. What is the ratio of the Aid received (current US$) of Tajikistan in 2010 to that in 2012?
Your answer should be very brief. 1.11. What is the ratio of the Aid received (current US$) in Upper middle income in 2010 to that in 2013?
Your answer should be very brief. 0.91. What is the ratio of the Aid received (current US$) of Guyana in 2010 to that in 2013?
Offer a very short reply. 1.64. What is the ratio of the Aid received (current US$) of Tajikistan in 2010 to that in 2013?
Your answer should be compact. 1.14. What is the ratio of the Aid received (current US$) in Upper middle income in 2011 to that in 2012?
Make the answer very short. 1.1. What is the ratio of the Aid received (current US$) of Guyana in 2011 to that in 2012?
Your response must be concise. 1.39. What is the ratio of the Aid received (current US$) of Tajikistan in 2011 to that in 2012?
Ensure brevity in your answer.  0.88. What is the ratio of the Aid received (current US$) of Upper middle income in 2011 to that in 2013?
Your answer should be compact. 1.19. What is the ratio of the Aid received (current US$) in Guyana in 2011 to that in 2013?
Give a very brief answer. 1.56. What is the ratio of the Aid received (current US$) of Tajikistan in 2011 to that in 2013?
Give a very brief answer. 0.91. What is the ratio of the Aid received (current US$) in Upper middle income in 2012 to that in 2013?
Your answer should be compact. 1.07. What is the ratio of the Aid received (current US$) in Guyana in 2012 to that in 2013?
Offer a very short reply. 1.12. What is the ratio of the Aid received (current US$) in Tajikistan in 2012 to that in 2013?
Your answer should be very brief. 1.03. What is the difference between the highest and the second highest Aid received (current US$) in Upper middle income?
Offer a very short reply. 2.98e+09. What is the difference between the highest and the second highest Aid received (current US$) of Guyana?
Make the answer very short. 9.70e+05. What is the difference between the highest and the second highest Aid received (current US$) in Tajikistan?
Keep it short and to the point. 2.85e+07. What is the difference between the highest and the lowest Aid received (current US$) of Upper middle income?
Make the answer very short. 1.00e+1. What is the difference between the highest and the lowest Aid received (current US$) of Guyana?
Provide a succinct answer. 7.24e+07. What is the difference between the highest and the lowest Aid received (current US$) in Tajikistan?
Your response must be concise. 2.15e+08. 